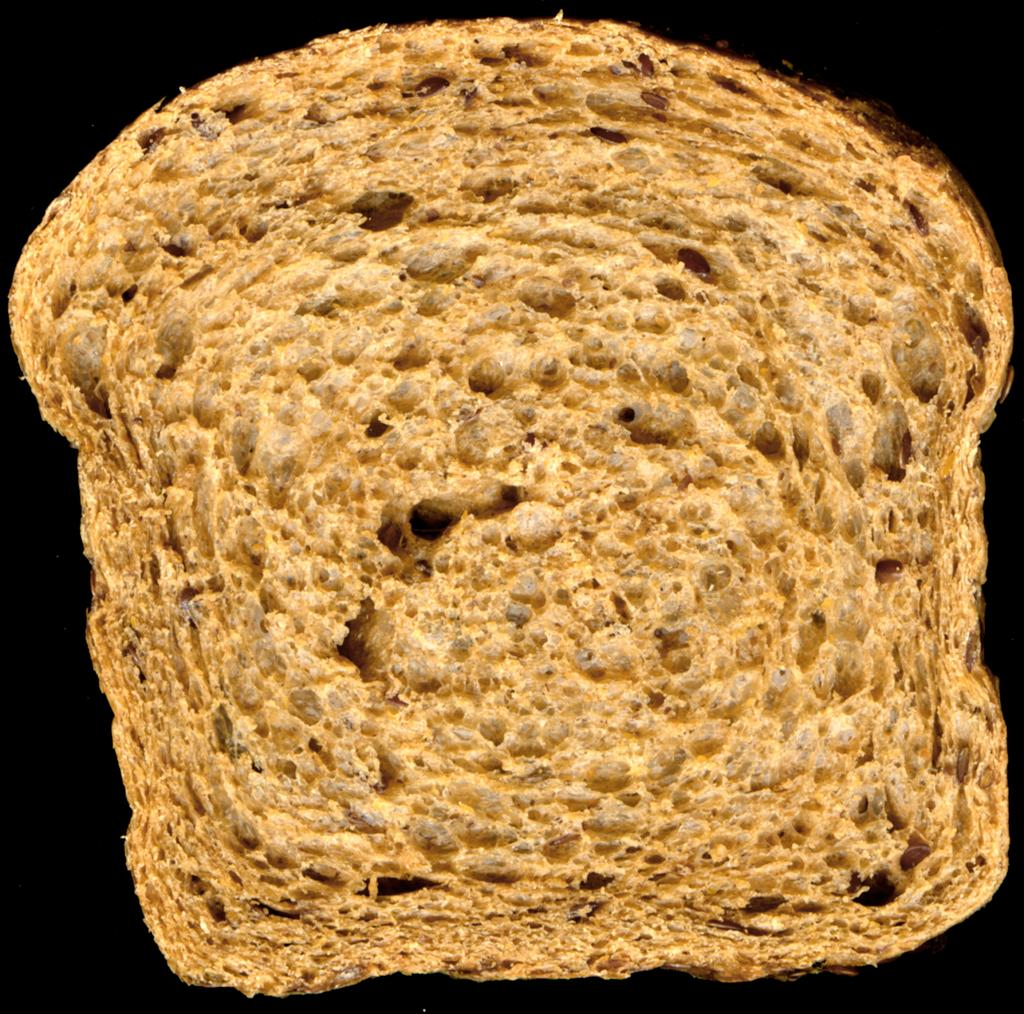What type of food is present in the image? There is a bread in the image. What can be observed about the background of the image? The background of the image is dark. What type of chair is depicted in the image? There is no chair present in the image; it only features a bread and a dark background. Can you solve the riddle that is written on the bread in the image? There is no riddle written on the bread in the image; it is simply a bread with a dark background. 